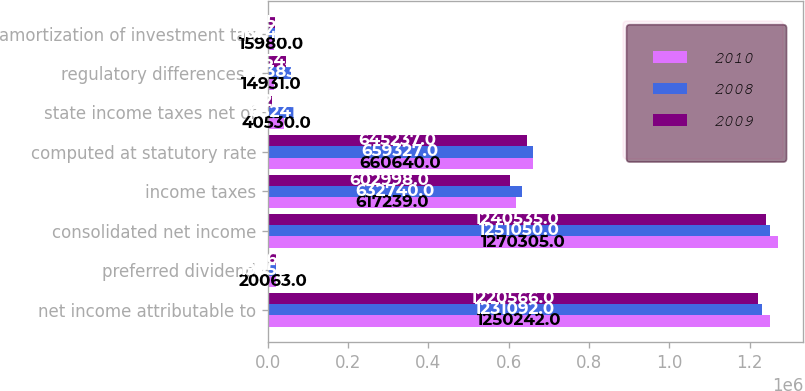Convert chart to OTSL. <chart><loc_0><loc_0><loc_500><loc_500><stacked_bar_chart><ecel><fcel>net income attributable to<fcel>preferred dividend<fcel>consolidated net income<fcel>income taxes<fcel>computed at statutory rate<fcel>state income taxes net of<fcel>regulatory differences -<fcel>amortization of investment tax<nl><fcel>2010<fcel>1.25024e+06<fcel>20063<fcel>1.2703e+06<fcel>617239<fcel>660640<fcel>40530<fcel>14931<fcel>15980<nl><fcel>2008<fcel>1.23109e+06<fcel>19958<fcel>1.25105e+06<fcel>632740<fcel>659327<fcel>65241<fcel>57383<fcel>16745<nl><fcel>2009<fcel>1.22057e+06<fcel>19969<fcel>1.24054e+06<fcel>602998<fcel>645237<fcel>9926<fcel>45543<fcel>17458<nl></chart> 